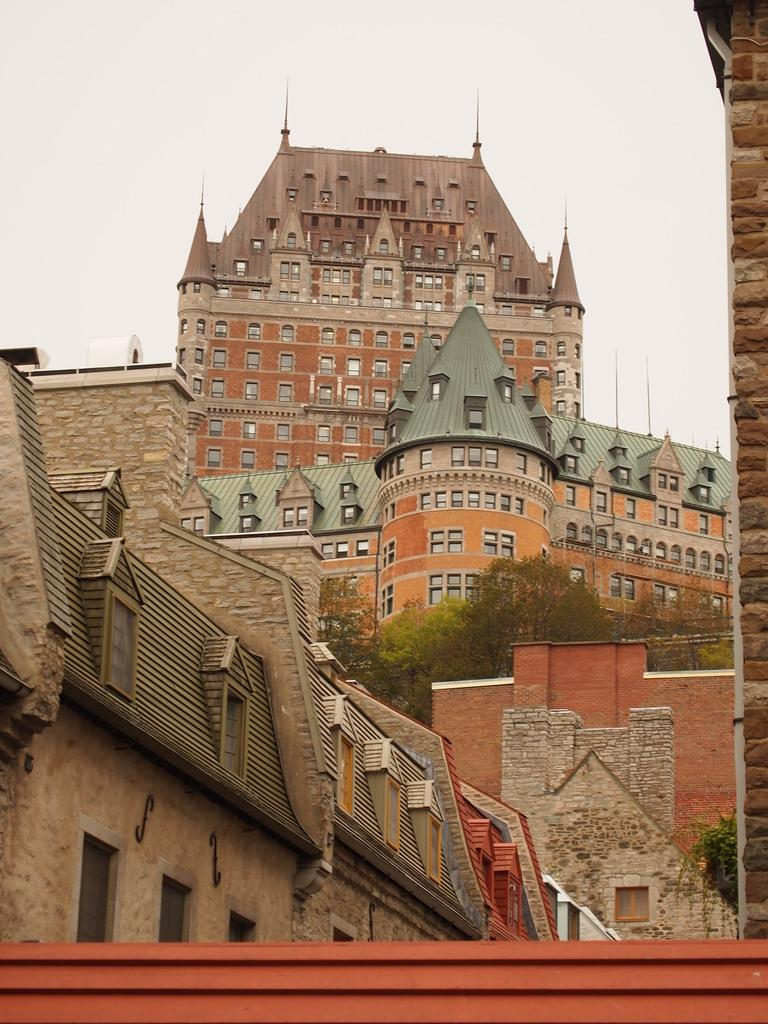What types of structures are present in the image? There are buildings in the image. What other natural elements can be seen in the image? There are trees in the image. What is visible in the background of the image? The sky is visible in the image. How many servants are visible in the image? There are no servants present in the image. What type of brick is used to construct the buildings in the image? There is no information about the type of brick used to construct the buildings in the image. 